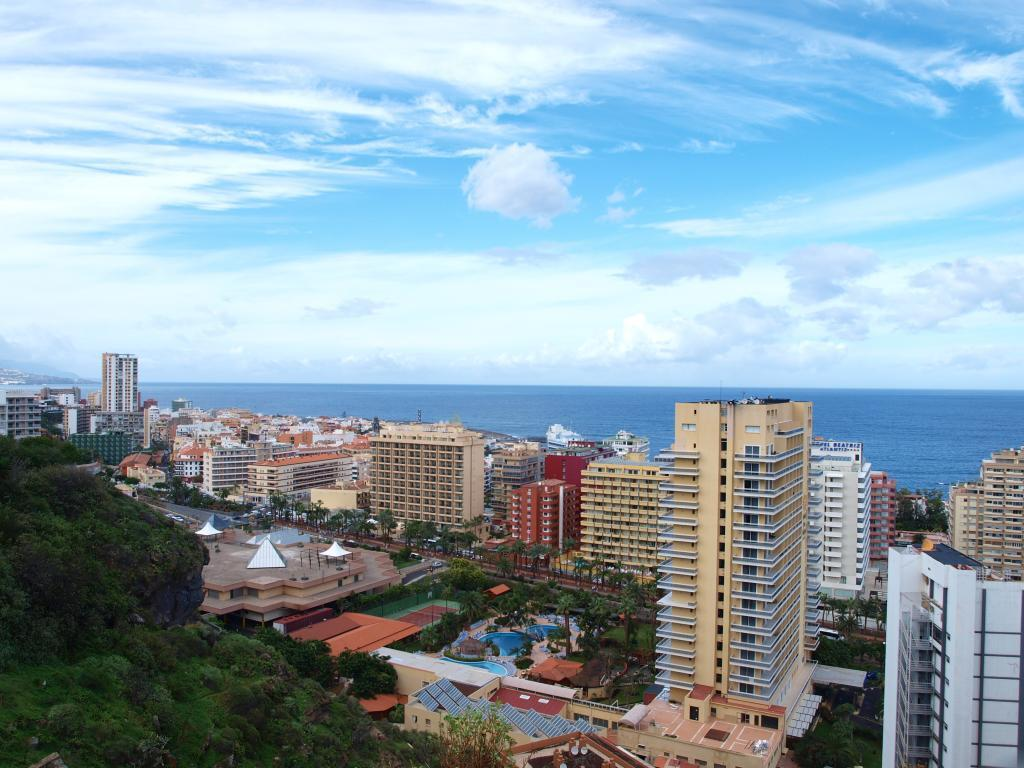What type of vegetation can be seen in the image? There is a group of trees in the image. What structures are present in the image? There are buildings in the image. What recreational feature is visible in the image? There is a swimming pool in the image. What is visible behind the buildings? Water is visible behind the buildings. What is the condition of the sky in the image? The sky is clear and visible at the top of the image. What type of skin condition can be seen on the trees in the image? There is no mention of any skin condition on the trees in the image. Is there an arch visible in the image? There is no mention of an arch in the image. 